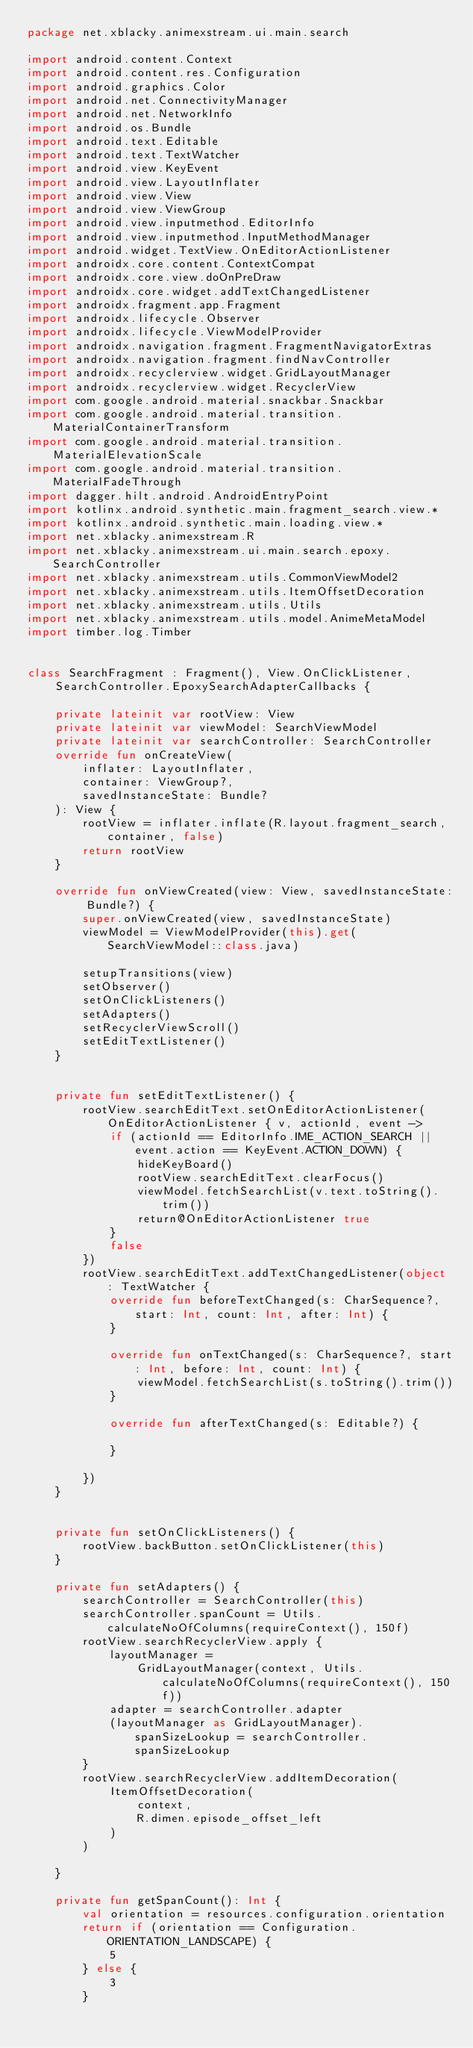<code> <loc_0><loc_0><loc_500><loc_500><_Kotlin_>package net.xblacky.animexstream.ui.main.search

import android.content.Context
import android.content.res.Configuration
import android.graphics.Color
import android.net.ConnectivityManager
import android.net.NetworkInfo
import android.os.Bundle
import android.text.Editable
import android.text.TextWatcher
import android.view.KeyEvent
import android.view.LayoutInflater
import android.view.View
import android.view.ViewGroup
import android.view.inputmethod.EditorInfo
import android.view.inputmethod.InputMethodManager
import android.widget.TextView.OnEditorActionListener
import androidx.core.content.ContextCompat
import androidx.core.view.doOnPreDraw
import androidx.core.widget.addTextChangedListener
import androidx.fragment.app.Fragment
import androidx.lifecycle.Observer
import androidx.lifecycle.ViewModelProvider
import androidx.navigation.fragment.FragmentNavigatorExtras
import androidx.navigation.fragment.findNavController
import androidx.recyclerview.widget.GridLayoutManager
import androidx.recyclerview.widget.RecyclerView
import com.google.android.material.snackbar.Snackbar
import com.google.android.material.transition.MaterialContainerTransform
import com.google.android.material.transition.MaterialElevationScale
import com.google.android.material.transition.MaterialFadeThrough
import dagger.hilt.android.AndroidEntryPoint
import kotlinx.android.synthetic.main.fragment_search.view.*
import kotlinx.android.synthetic.main.loading.view.*
import net.xblacky.animexstream.R
import net.xblacky.animexstream.ui.main.search.epoxy.SearchController
import net.xblacky.animexstream.utils.CommonViewModel2
import net.xblacky.animexstream.utils.ItemOffsetDecoration
import net.xblacky.animexstream.utils.Utils
import net.xblacky.animexstream.utils.model.AnimeMetaModel
import timber.log.Timber


class SearchFragment : Fragment(), View.OnClickListener,
    SearchController.EpoxySearchAdapterCallbacks {

    private lateinit var rootView: View
    private lateinit var viewModel: SearchViewModel
    private lateinit var searchController: SearchController
    override fun onCreateView(
        inflater: LayoutInflater,
        container: ViewGroup?,
        savedInstanceState: Bundle?
    ): View {
        rootView = inflater.inflate(R.layout.fragment_search, container, false)
        return rootView
    }

    override fun onViewCreated(view: View, savedInstanceState: Bundle?) {
        super.onViewCreated(view, savedInstanceState)
        viewModel = ViewModelProvider(this).get(SearchViewModel::class.java)

        setupTransitions(view)
        setObserver()
        setOnClickListeners()
        setAdapters()
        setRecyclerViewScroll()
        setEditTextListener()
    }


    private fun setEditTextListener() {
        rootView.searchEditText.setOnEditorActionListener(OnEditorActionListener { v, actionId, event ->
            if (actionId == EditorInfo.IME_ACTION_SEARCH || event.action == KeyEvent.ACTION_DOWN) {
                hideKeyBoard()
                rootView.searchEditText.clearFocus()
                viewModel.fetchSearchList(v.text.toString().trim())
                return@OnEditorActionListener true
            }
            false
        })
        rootView.searchEditText.addTextChangedListener(object : TextWatcher {
            override fun beforeTextChanged(s: CharSequence?, start: Int, count: Int, after: Int) {
            }

            override fun onTextChanged(s: CharSequence?, start: Int, before: Int, count: Int) {
                viewModel.fetchSearchList(s.toString().trim())
            }

            override fun afterTextChanged(s: Editable?) {

            }

        })
    }


    private fun setOnClickListeners() {
        rootView.backButton.setOnClickListener(this)
    }

    private fun setAdapters() {
        searchController = SearchController(this)
        searchController.spanCount = Utils.calculateNoOfColumns(requireContext(), 150f)
        rootView.searchRecyclerView.apply {
            layoutManager =
                GridLayoutManager(context, Utils.calculateNoOfColumns(requireContext(), 150f))
            adapter = searchController.adapter
            (layoutManager as GridLayoutManager).spanSizeLookup = searchController.spanSizeLookup
        }
        rootView.searchRecyclerView.addItemDecoration(
            ItemOffsetDecoration(
                context,
                R.dimen.episode_offset_left
            )
        )

    }

    private fun getSpanCount(): Int {
        val orientation = resources.configuration.orientation
        return if (orientation == Configuration.ORIENTATION_LANDSCAPE) {
            5
        } else {
            3
        }</code> 